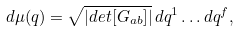Convert formula to latex. <formula><loc_0><loc_0><loc_500><loc_500>d \mu ( q ) = \sqrt { | d e t [ G _ { a b } ] | } \, d q ^ { 1 } \dots d q ^ { f } ,</formula> 